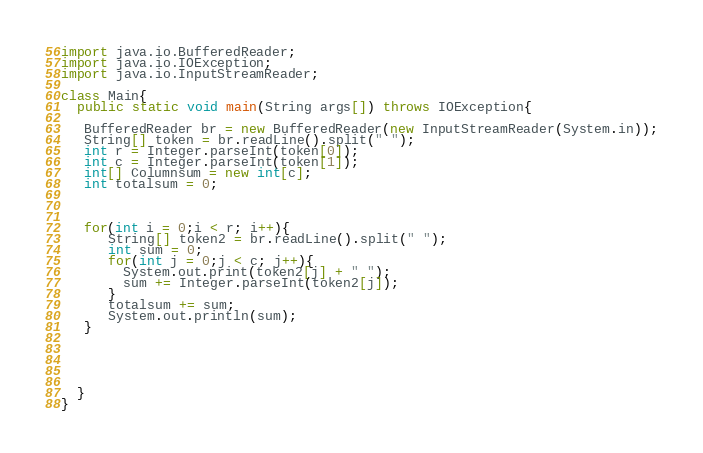<code> <loc_0><loc_0><loc_500><loc_500><_Java_>import java.io.BufferedReader;
import java.io.IOException;
import java.io.InputStreamReader;
 
class Main{
  public static void main(String args[]) throws IOException{
   
   BufferedReader br = new BufferedReader(new InputStreamReader(System.in));
   String[] token = br.readLine().split(" ");
   int r = Integer.parseInt(token[0]);      
   int c = Integer.parseInt(token[1]);   
   int[] Columnsum = new int[c];
   int totalsum = 0;  
  
   
  
   for(int i = 0;i < r; i++){
      String[] token2 = br.readLine().split(" ");
      int sum = 0;
      for(int j = 0;j < c; j++){      
        System.out.print(token2[j] + " ");
        sum += Integer.parseInt(token2[j]);
      }
      totalsum += sum;
      System.out.println(sum);
   }




    
  }
}</code> 